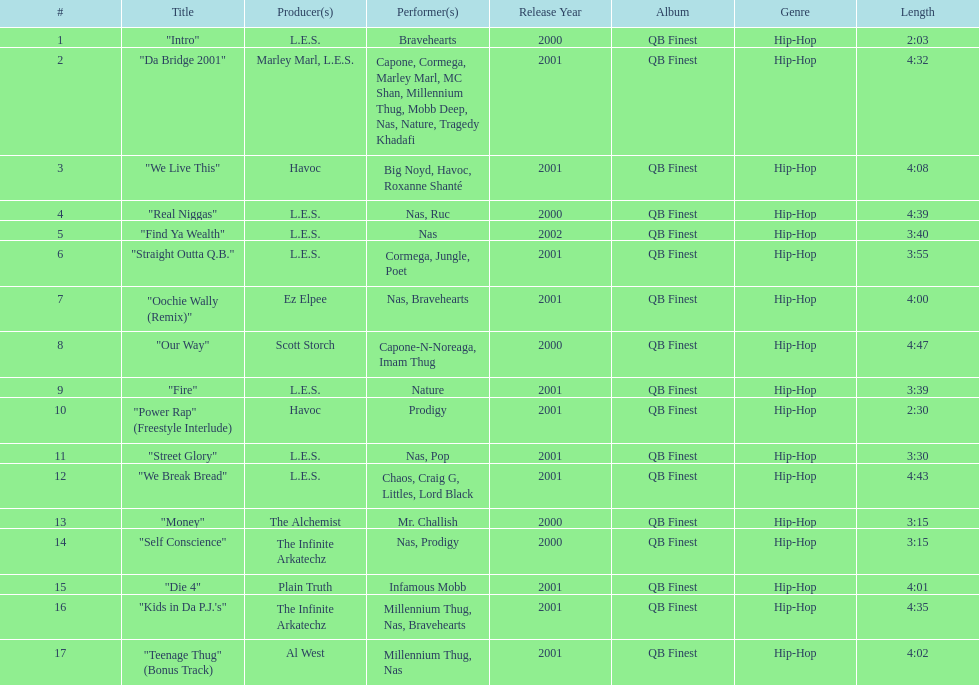Which is longer, fire or die 4? "Die 4". 